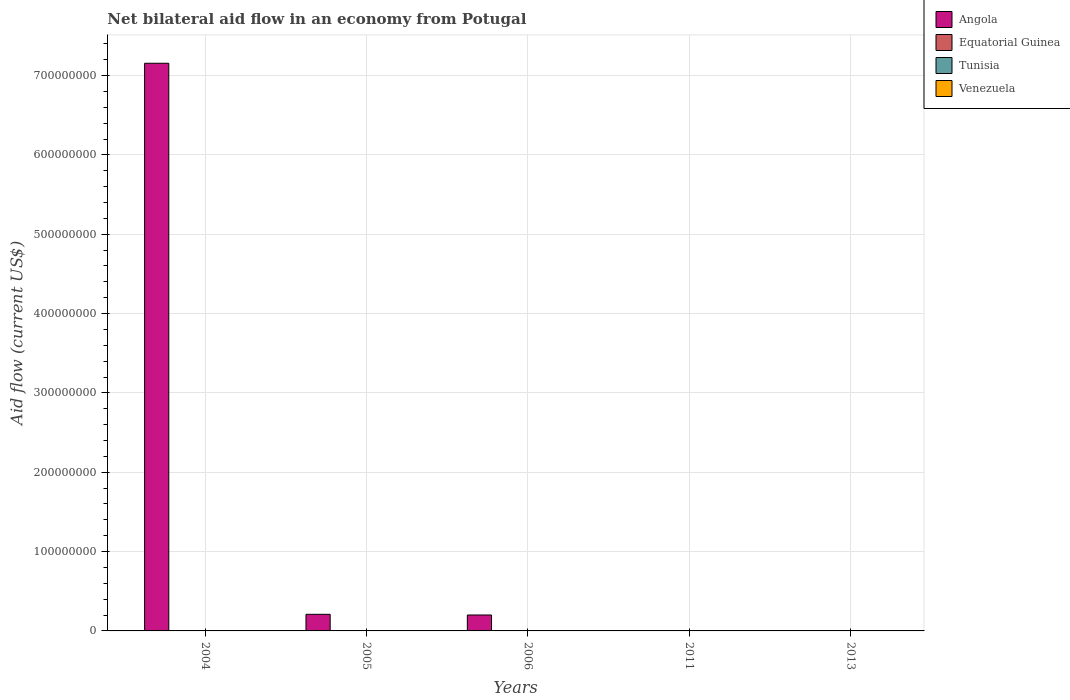How many different coloured bars are there?
Your answer should be very brief. 4. How many bars are there on the 2nd tick from the left?
Ensure brevity in your answer.  4. How many bars are there on the 5th tick from the right?
Give a very brief answer. 4. What is the label of the 5th group of bars from the left?
Your response must be concise. 2013. In how many cases, is the number of bars for a given year not equal to the number of legend labels?
Offer a very short reply. 2. What is the net bilateral aid flow in Angola in 2004?
Give a very brief answer. 7.15e+08. Across all years, what is the maximum net bilateral aid flow in Venezuela?
Offer a very short reply. 1.40e+05. Across all years, what is the minimum net bilateral aid flow in Equatorial Guinea?
Ensure brevity in your answer.  10000. What is the total net bilateral aid flow in Angola in the graph?
Make the answer very short. 7.56e+08. What is the average net bilateral aid flow in Equatorial Guinea per year?
Make the answer very short. 4.00e+04. In the year 2006, what is the difference between the net bilateral aid flow in Angola and net bilateral aid flow in Equatorial Guinea?
Ensure brevity in your answer.  2.00e+07. What is the ratio of the net bilateral aid flow in Venezuela in 2005 to that in 2013?
Provide a short and direct response. 0.71. What is the difference between the highest and the lowest net bilateral aid flow in Equatorial Guinea?
Offer a very short reply. 4.00e+04. In how many years, is the net bilateral aid flow in Tunisia greater than the average net bilateral aid flow in Tunisia taken over all years?
Provide a succinct answer. 3. Is the sum of the net bilateral aid flow in Tunisia in 2005 and 2011 greater than the maximum net bilateral aid flow in Angola across all years?
Your answer should be compact. No. Is it the case that in every year, the sum of the net bilateral aid flow in Venezuela and net bilateral aid flow in Equatorial Guinea is greater than the net bilateral aid flow in Tunisia?
Provide a short and direct response. Yes. How many bars are there?
Make the answer very short. 18. Are all the bars in the graph horizontal?
Provide a succinct answer. No. Does the graph contain any zero values?
Keep it short and to the point. Yes. How many legend labels are there?
Keep it short and to the point. 4. What is the title of the graph?
Your answer should be compact. Net bilateral aid flow in an economy from Potugal. What is the label or title of the X-axis?
Your response must be concise. Years. What is the Aid flow (current US$) in Angola in 2004?
Offer a terse response. 7.15e+08. What is the Aid flow (current US$) in Tunisia in 2004?
Your answer should be very brief. 6.00e+04. What is the Aid flow (current US$) of Angola in 2005?
Offer a very short reply. 2.09e+07. What is the Aid flow (current US$) in Tunisia in 2005?
Your answer should be very brief. 7.00e+04. What is the Aid flow (current US$) of Venezuela in 2005?
Provide a succinct answer. 1.00e+05. What is the Aid flow (current US$) in Angola in 2006?
Make the answer very short. 2.01e+07. What is the Aid flow (current US$) in Equatorial Guinea in 2006?
Ensure brevity in your answer.  5.00e+04. What is the Aid flow (current US$) in Tunisia in 2006?
Your answer should be very brief. 5.00e+04. What is the Aid flow (current US$) in Venezuela in 2006?
Provide a short and direct response. 1.10e+05. What is the Aid flow (current US$) in Venezuela in 2011?
Give a very brief answer. 9.00e+04. Across all years, what is the maximum Aid flow (current US$) in Angola?
Your response must be concise. 7.15e+08. Across all years, what is the maximum Aid flow (current US$) of Venezuela?
Your answer should be very brief. 1.40e+05. What is the total Aid flow (current US$) in Angola in the graph?
Make the answer very short. 7.56e+08. What is the total Aid flow (current US$) of Equatorial Guinea in the graph?
Provide a succinct answer. 2.00e+05. What is the total Aid flow (current US$) in Venezuela in the graph?
Ensure brevity in your answer.  5.20e+05. What is the difference between the Aid flow (current US$) of Angola in 2004 and that in 2005?
Your answer should be compact. 6.95e+08. What is the difference between the Aid flow (current US$) in Equatorial Guinea in 2004 and that in 2005?
Keep it short and to the point. 0. What is the difference between the Aid flow (current US$) in Tunisia in 2004 and that in 2005?
Provide a short and direct response. -10000. What is the difference between the Aid flow (current US$) in Angola in 2004 and that in 2006?
Your response must be concise. 6.95e+08. What is the difference between the Aid flow (current US$) of Tunisia in 2004 and that in 2006?
Your answer should be compact. 10000. What is the difference between the Aid flow (current US$) in Venezuela in 2004 and that in 2013?
Provide a short and direct response. -6.00e+04. What is the difference between the Aid flow (current US$) of Angola in 2005 and that in 2006?
Your answer should be compact. 8.50e+05. What is the difference between the Aid flow (current US$) in Venezuela in 2005 and that in 2011?
Your answer should be compact. 10000. What is the difference between the Aid flow (current US$) of Equatorial Guinea in 2005 and that in 2013?
Provide a succinct answer. 10000. What is the difference between the Aid flow (current US$) in Venezuela in 2006 and that in 2011?
Offer a very short reply. 2.00e+04. What is the difference between the Aid flow (current US$) of Equatorial Guinea in 2006 and that in 2013?
Offer a terse response. 10000. What is the difference between the Aid flow (current US$) of Tunisia in 2011 and that in 2013?
Make the answer very short. -5.00e+04. What is the difference between the Aid flow (current US$) of Venezuela in 2011 and that in 2013?
Make the answer very short. -5.00e+04. What is the difference between the Aid flow (current US$) of Angola in 2004 and the Aid flow (current US$) of Equatorial Guinea in 2005?
Provide a short and direct response. 7.15e+08. What is the difference between the Aid flow (current US$) of Angola in 2004 and the Aid flow (current US$) of Tunisia in 2005?
Give a very brief answer. 7.15e+08. What is the difference between the Aid flow (current US$) in Angola in 2004 and the Aid flow (current US$) in Venezuela in 2005?
Provide a succinct answer. 7.15e+08. What is the difference between the Aid flow (current US$) of Equatorial Guinea in 2004 and the Aid flow (current US$) of Tunisia in 2005?
Your answer should be very brief. -2.00e+04. What is the difference between the Aid flow (current US$) of Angola in 2004 and the Aid flow (current US$) of Equatorial Guinea in 2006?
Offer a very short reply. 7.15e+08. What is the difference between the Aid flow (current US$) of Angola in 2004 and the Aid flow (current US$) of Tunisia in 2006?
Ensure brevity in your answer.  7.15e+08. What is the difference between the Aid flow (current US$) in Angola in 2004 and the Aid flow (current US$) in Venezuela in 2006?
Provide a succinct answer. 7.15e+08. What is the difference between the Aid flow (current US$) in Equatorial Guinea in 2004 and the Aid flow (current US$) in Tunisia in 2006?
Provide a succinct answer. 0. What is the difference between the Aid flow (current US$) in Equatorial Guinea in 2004 and the Aid flow (current US$) in Venezuela in 2006?
Your answer should be very brief. -6.00e+04. What is the difference between the Aid flow (current US$) in Angola in 2004 and the Aid flow (current US$) in Equatorial Guinea in 2011?
Provide a succinct answer. 7.15e+08. What is the difference between the Aid flow (current US$) of Angola in 2004 and the Aid flow (current US$) of Tunisia in 2011?
Give a very brief answer. 7.15e+08. What is the difference between the Aid flow (current US$) of Angola in 2004 and the Aid flow (current US$) of Venezuela in 2011?
Provide a short and direct response. 7.15e+08. What is the difference between the Aid flow (current US$) in Tunisia in 2004 and the Aid flow (current US$) in Venezuela in 2011?
Your answer should be very brief. -3.00e+04. What is the difference between the Aid flow (current US$) of Angola in 2004 and the Aid flow (current US$) of Equatorial Guinea in 2013?
Your response must be concise. 7.15e+08. What is the difference between the Aid flow (current US$) in Angola in 2004 and the Aid flow (current US$) in Tunisia in 2013?
Keep it short and to the point. 7.15e+08. What is the difference between the Aid flow (current US$) in Angola in 2004 and the Aid flow (current US$) in Venezuela in 2013?
Provide a short and direct response. 7.15e+08. What is the difference between the Aid flow (current US$) in Equatorial Guinea in 2004 and the Aid flow (current US$) in Venezuela in 2013?
Your answer should be compact. -9.00e+04. What is the difference between the Aid flow (current US$) in Tunisia in 2004 and the Aid flow (current US$) in Venezuela in 2013?
Provide a short and direct response. -8.00e+04. What is the difference between the Aid flow (current US$) of Angola in 2005 and the Aid flow (current US$) of Equatorial Guinea in 2006?
Offer a very short reply. 2.09e+07. What is the difference between the Aid flow (current US$) of Angola in 2005 and the Aid flow (current US$) of Tunisia in 2006?
Provide a short and direct response. 2.09e+07. What is the difference between the Aid flow (current US$) in Angola in 2005 and the Aid flow (current US$) in Venezuela in 2006?
Your answer should be very brief. 2.08e+07. What is the difference between the Aid flow (current US$) of Equatorial Guinea in 2005 and the Aid flow (current US$) of Venezuela in 2006?
Provide a succinct answer. -6.00e+04. What is the difference between the Aid flow (current US$) in Tunisia in 2005 and the Aid flow (current US$) in Venezuela in 2006?
Offer a very short reply. -4.00e+04. What is the difference between the Aid flow (current US$) of Angola in 2005 and the Aid flow (current US$) of Equatorial Guinea in 2011?
Your answer should be compact. 2.09e+07. What is the difference between the Aid flow (current US$) in Angola in 2005 and the Aid flow (current US$) in Tunisia in 2011?
Your answer should be very brief. 2.09e+07. What is the difference between the Aid flow (current US$) in Angola in 2005 and the Aid flow (current US$) in Venezuela in 2011?
Give a very brief answer. 2.08e+07. What is the difference between the Aid flow (current US$) in Equatorial Guinea in 2005 and the Aid flow (current US$) in Tunisia in 2011?
Offer a terse response. 4.00e+04. What is the difference between the Aid flow (current US$) in Equatorial Guinea in 2005 and the Aid flow (current US$) in Venezuela in 2011?
Ensure brevity in your answer.  -4.00e+04. What is the difference between the Aid flow (current US$) of Tunisia in 2005 and the Aid flow (current US$) of Venezuela in 2011?
Your answer should be compact. -2.00e+04. What is the difference between the Aid flow (current US$) in Angola in 2005 and the Aid flow (current US$) in Equatorial Guinea in 2013?
Ensure brevity in your answer.  2.09e+07. What is the difference between the Aid flow (current US$) in Angola in 2005 and the Aid flow (current US$) in Tunisia in 2013?
Make the answer very short. 2.09e+07. What is the difference between the Aid flow (current US$) in Angola in 2005 and the Aid flow (current US$) in Venezuela in 2013?
Provide a short and direct response. 2.08e+07. What is the difference between the Aid flow (current US$) of Equatorial Guinea in 2005 and the Aid flow (current US$) of Tunisia in 2013?
Make the answer very short. -10000. What is the difference between the Aid flow (current US$) of Equatorial Guinea in 2005 and the Aid flow (current US$) of Venezuela in 2013?
Offer a terse response. -9.00e+04. What is the difference between the Aid flow (current US$) in Tunisia in 2005 and the Aid flow (current US$) in Venezuela in 2013?
Offer a terse response. -7.00e+04. What is the difference between the Aid flow (current US$) in Angola in 2006 and the Aid flow (current US$) in Equatorial Guinea in 2011?
Your answer should be very brief. 2.01e+07. What is the difference between the Aid flow (current US$) in Angola in 2006 and the Aid flow (current US$) in Tunisia in 2011?
Ensure brevity in your answer.  2.01e+07. What is the difference between the Aid flow (current US$) of Angola in 2006 and the Aid flow (current US$) of Venezuela in 2011?
Provide a succinct answer. 2.00e+07. What is the difference between the Aid flow (current US$) of Tunisia in 2006 and the Aid flow (current US$) of Venezuela in 2011?
Provide a succinct answer. -4.00e+04. What is the difference between the Aid flow (current US$) of Angola in 2006 and the Aid flow (current US$) of Equatorial Guinea in 2013?
Ensure brevity in your answer.  2.00e+07. What is the difference between the Aid flow (current US$) in Angola in 2006 and the Aid flow (current US$) in Tunisia in 2013?
Give a very brief answer. 2.00e+07. What is the difference between the Aid flow (current US$) in Angola in 2006 and the Aid flow (current US$) in Venezuela in 2013?
Make the answer very short. 1.99e+07. What is the difference between the Aid flow (current US$) in Equatorial Guinea in 2006 and the Aid flow (current US$) in Venezuela in 2013?
Ensure brevity in your answer.  -9.00e+04. What is the difference between the Aid flow (current US$) of Tunisia in 2006 and the Aid flow (current US$) of Venezuela in 2013?
Offer a very short reply. -9.00e+04. What is the difference between the Aid flow (current US$) in Equatorial Guinea in 2011 and the Aid flow (current US$) in Tunisia in 2013?
Provide a short and direct response. -5.00e+04. What is the average Aid flow (current US$) in Angola per year?
Your response must be concise. 1.51e+08. What is the average Aid flow (current US$) in Equatorial Guinea per year?
Your response must be concise. 4.00e+04. What is the average Aid flow (current US$) of Venezuela per year?
Make the answer very short. 1.04e+05. In the year 2004, what is the difference between the Aid flow (current US$) in Angola and Aid flow (current US$) in Equatorial Guinea?
Offer a very short reply. 7.15e+08. In the year 2004, what is the difference between the Aid flow (current US$) of Angola and Aid flow (current US$) of Tunisia?
Offer a terse response. 7.15e+08. In the year 2004, what is the difference between the Aid flow (current US$) of Angola and Aid flow (current US$) of Venezuela?
Offer a terse response. 7.15e+08. In the year 2004, what is the difference between the Aid flow (current US$) in Equatorial Guinea and Aid flow (current US$) in Tunisia?
Keep it short and to the point. -10000. In the year 2004, what is the difference between the Aid flow (current US$) of Equatorial Guinea and Aid flow (current US$) of Venezuela?
Keep it short and to the point. -3.00e+04. In the year 2005, what is the difference between the Aid flow (current US$) in Angola and Aid flow (current US$) in Equatorial Guinea?
Provide a succinct answer. 2.09e+07. In the year 2005, what is the difference between the Aid flow (current US$) in Angola and Aid flow (current US$) in Tunisia?
Make the answer very short. 2.09e+07. In the year 2005, what is the difference between the Aid flow (current US$) in Angola and Aid flow (current US$) in Venezuela?
Offer a very short reply. 2.08e+07. In the year 2005, what is the difference between the Aid flow (current US$) in Equatorial Guinea and Aid flow (current US$) in Tunisia?
Give a very brief answer. -2.00e+04. In the year 2005, what is the difference between the Aid flow (current US$) of Tunisia and Aid flow (current US$) of Venezuela?
Make the answer very short. -3.00e+04. In the year 2006, what is the difference between the Aid flow (current US$) of Angola and Aid flow (current US$) of Equatorial Guinea?
Make the answer very short. 2.00e+07. In the year 2006, what is the difference between the Aid flow (current US$) in Angola and Aid flow (current US$) in Tunisia?
Your answer should be very brief. 2.00e+07. In the year 2006, what is the difference between the Aid flow (current US$) in Angola and Aid flow (current US$) in Venezuela?
Your answer should be compact. 2.00e+07. In the year 2006, what is the difference between the Aid flow (current US$) of Equatorial Guinea and Aid flow (current US$) of Tunisia?
Offer a very short reply. 0. In the year 2011, what is the difference between the Aid flow (current US$) of Equatorial Guinea and Aid flow (current US$) of Tunisia?
Your answer should be very brief. 0. In the year 2011, what is the difference between the Aid flow (current US$) of Equatorial Guinea and Aid flow (current US$) of Venezuela?
Make the answer very short. -8.00e+04. In the year 2013, what is the difference between the Aid flow (current US$) of Equatorial Guinea and Aid flow (current US$) of Venezuela?
Keep it short and to the point. -1.00e+05. What is the ratio of the Aid flow (current US$) in Angola in 2004 to that in 2005?
Ensure brevity in your answer.  34.18. What is the ratio of the Aid flow (current US$) of Venezuela in 2004 to that in 2005?
Make the answer very short. 0.8. What is the ratio of the Aid flow (current US$) in Angola in 2004 to that in 2006?
Provide a succinct answer. 35.63. What is the ratio of the Aid flow (current US$) in Equatorial Guinea in 2004 to that in 2006?
Provide a succinct answer. 1. What is the ratio of the Aid flow (current US$) in Venezuela in 2004 to that in 2006?
Give a very brief answer. 0.73. What is the ratio of the Aid flow (current US$) of Equatorial Guinea in 2004 to that in 2011?
Your answer should be very brief. 5. What is the ratio of the Aid flow (current US$) of Tunisia in 2004 to that in 2011?
Make the answer very short. 6. What is the ratio of the Aid flow (current US$) in Venezuela in 2004 to that in 2011?
Keep it short and to the point. 0.89. What is the ratio of the Aid flow (current US$) in Equatorial Guinea in 2004 to that in 2013?
Provide a succinct answer. 1.25. What is the ratio of the Aid flow (current US$) of Tunisia in 2004 to that in 2013?
Offer a terse response. 1. What is the ratio of the Aid flow (current US$) of Angola in 2005 to that in 2006?
Offer a very short reply. 1.04. What is the ratio of the Aid flow (current US$) in Venezuela in 2005 to that in 2011?
Your response must be concise. 1.11. What is the ratio of the Aid flow (current US$) of Equatorial Guinea in 2005 to that in 2013?
Give a very brief answer. 1.25. What is the ratio of the Aid flow (current US$) in Tunisia in 2005 to that in 2013?
Make the answer very short. 1.17. What is the ratio of the Aid flow (current US$) of Venezuela in 2005 to that in 2013?
Offer a terse response. 0.71. What is the ratio of the Aid flow (current US$) in Equatorial Guinea in 2006 to that in 2011?
Ensure brevity in your answer.  5. What is the ratio of the Aid flow (current US$) of Venezuela in 2006 to that in 2011?
Ensure brevity in your answer.  1.22. What is the ratio of the Aid flow (current US$) of Tunisia in 2006 to that in 2013?
Provide a short and direct response. 0.83. What is the ratio of the Aid flow (current US$) in Venezuela in 2006 to that in 2013?
Provide a short and direct response. 0.79. What is the ratio of the Aid flow (current US$) in Venezuela in 2011 to that in 2013?
Make the answer very short. 0.64. What is the difference between the highest and the second highest Aid flow (current US$) of Angola?
Ensure brevity in your answer.  6.95e+08. What is the difference between the highest and the second highest Aid flow (current US$) of Equatorial Guinea?
Your response must be concise. 0. What is the difference between the highest and the second highest Aid flow (current US$) in Venezuela?
Give a very brief answer. 3.00e+04. What is the difference between the highest and the lowest Aid flow (current US$) in Angola?
Give a very brief answer. 7.15e+08. 